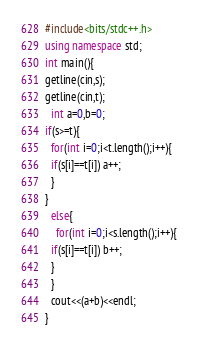<code> <loc_0><loc_0><loc_500><loc_500><_C++_>#include<bits/stdc++.h>
using namespace std;
int main(){
getline(cin,s);
getline(cin,t);
  int a=0,b=0;
if(s>=t){
  for(int i=0;i<t.length();i++){
  if(s[i]==t[i]) a++;
  }
}
  else{
    for(int i=0;i<s.length();i++){
  if(s[i]==t[i]) b++;
  }
  }
  cout<<(a+b)<<endl;
}</code> 